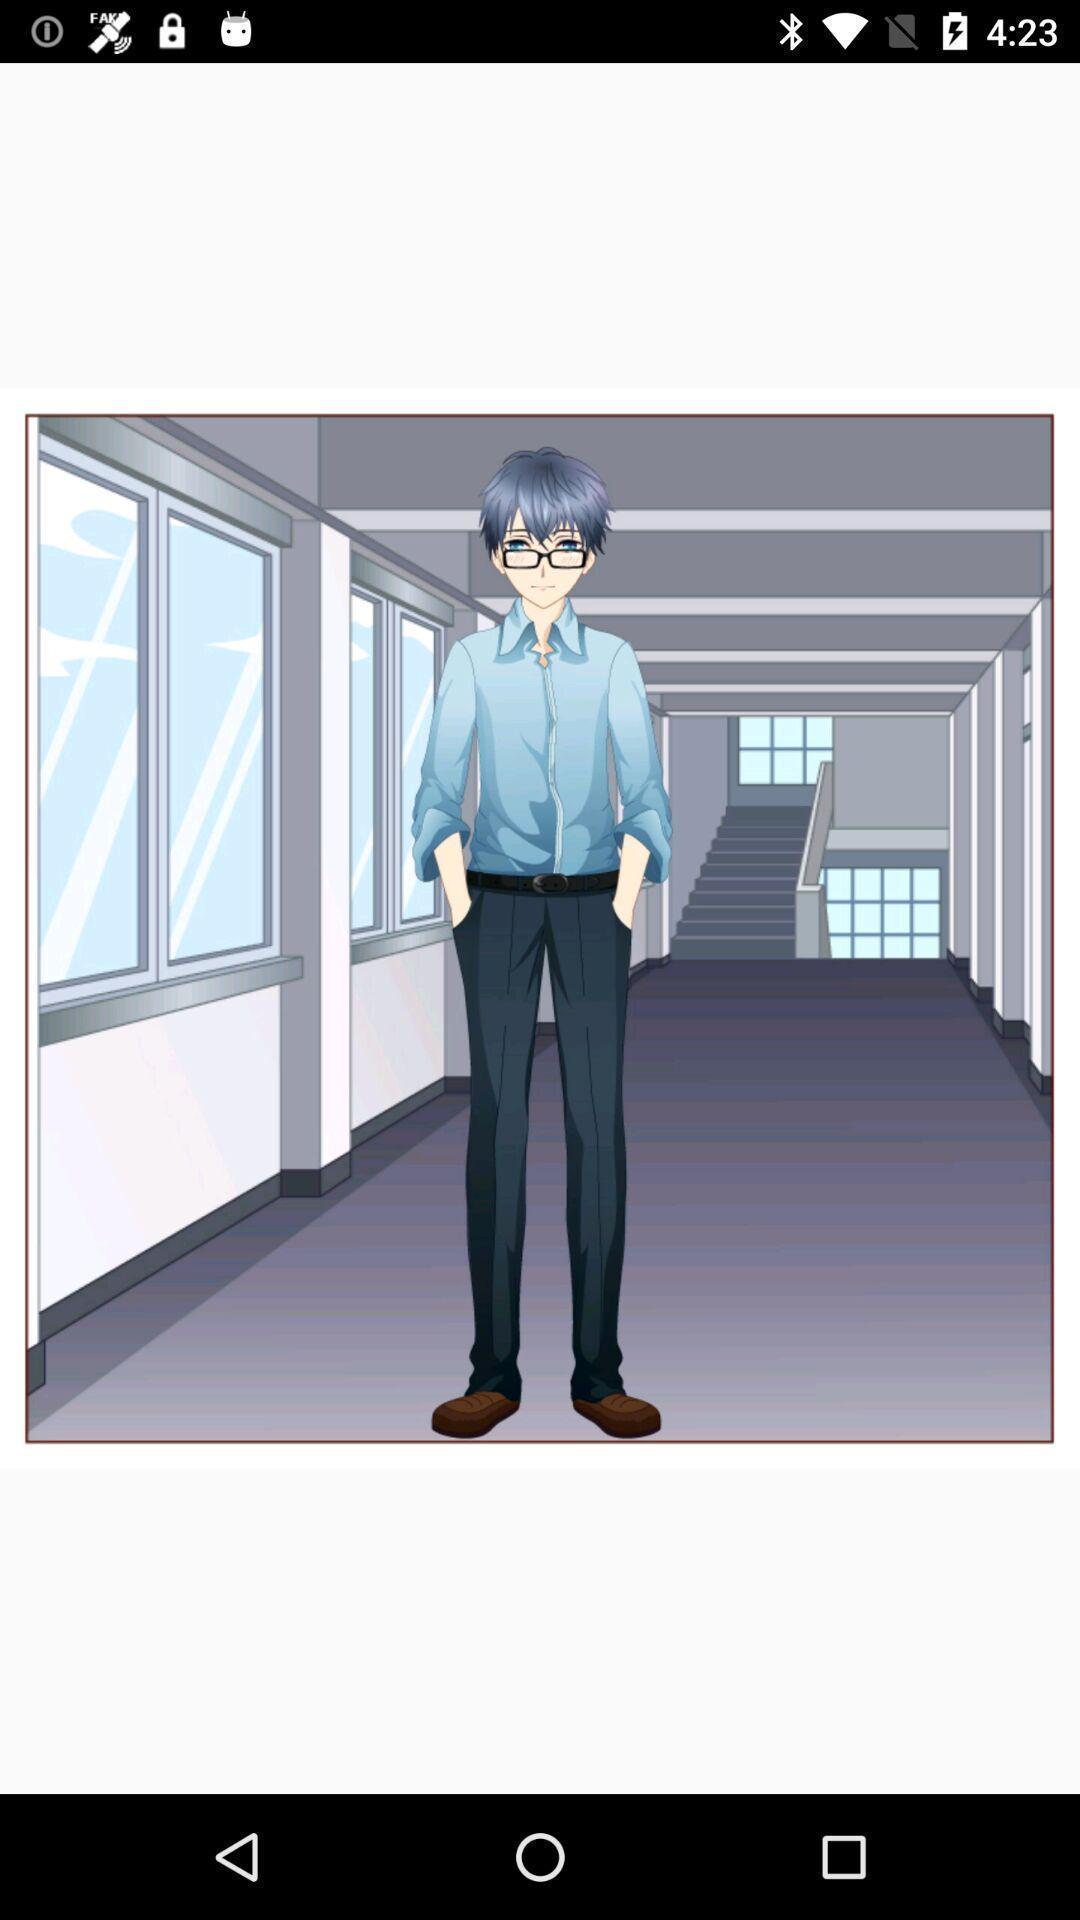Summarize the main components in this picture. Screen shows an image of a person. 